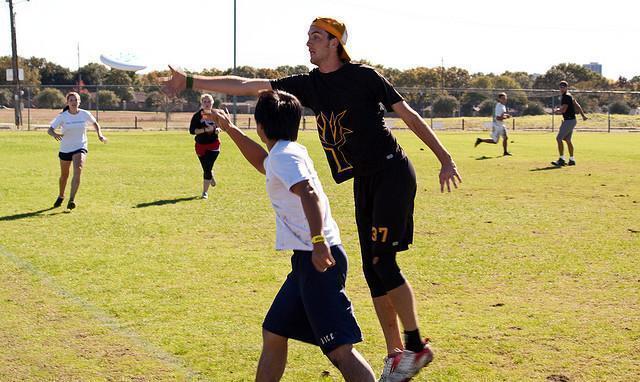What sport are the people playing?
Select the accurate answer and provide explanation: 'Answer: answer
Rationale: rationale.'
Options: Ultimate frisbee, baseball, football, field hockey. Answer: ultimate frisbee.
Rationale: The people are in a field and throwing a frisbee around for fun. 